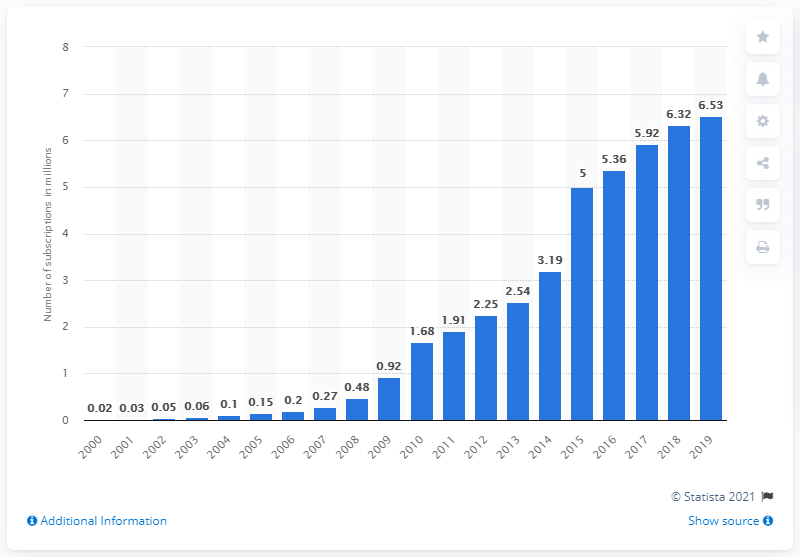Specify some key components in this picture. In 2019, the number of mobile subscriptions in Burundi was approximately 6.53 million. 